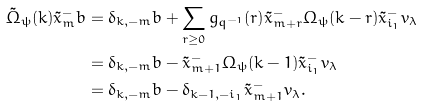Convert formula to latex. <formula><loc_0><loc_0><loc_500><loc_500>\tilde { \Omega } _ { \psi } ( k ) \tilde { x } ^ { - } _ { m } b & = \delta _ { k , - m } b + \sum _ { r \geq 0 } g _ { q ^ { - 1 } } ( r ) \tilde { x } ^ { - } _ { m + r } \Omega _ { \psi } ( k - r ) \tilde { x } _ { i _ { 1 } } ^ { - } v _ { \lambda } \\ & = \delta _ { k , - m } b - \tilde { x } ^ { - } _ { m + 1 } \Omega _ { \psi } ( k - 1 ) \tilde { x } _ { i _ { 1 } } ^ { - } v _ { \lambda } \\ & = \delta _ { k , - m } b - \delta _ { k - 1 , - i _ { 1 } } \tilde { x } ^ { - } _ { m + 1 } v _ { \lambda } .</formula> 